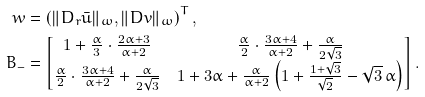<formula> <loc_0><loc_0><loc_500><loc_500>w & = \left ( \| D _ { r } \bar { u } \| _ { \omega } , \| D v \| _ { \omega } \right ) ^ { T } , \\ B _ { - } & = \begin{bmatrix} 1 + \frac { \alpha } { 3 } \cdot \frac { 2 \alpha + 3 } { \alpha + 2 } & \frac { \alpha } { 2 } \cdot \frac { 3 \alpha + 4 } { \alpha + 2 } + \frac { \alpha } { 2 \sqrt { 3 } } \\ \frac { \alpha } { 2 } \cdot \frac { 3 \alpha + 4 } { \alpha + 2 } + \frac { \alpha } { 2 \sqrt { 3 } } & 1 + 3 \alpha + \frac { \alpha } { \alpha + 2 } \left ( 1 + \frac { 1 + \sqrt { 3 } } { \sqrt { 2 } } - \sqrt { 3 } \, \alpha \right ) \end{bmatrix} .</formula> 